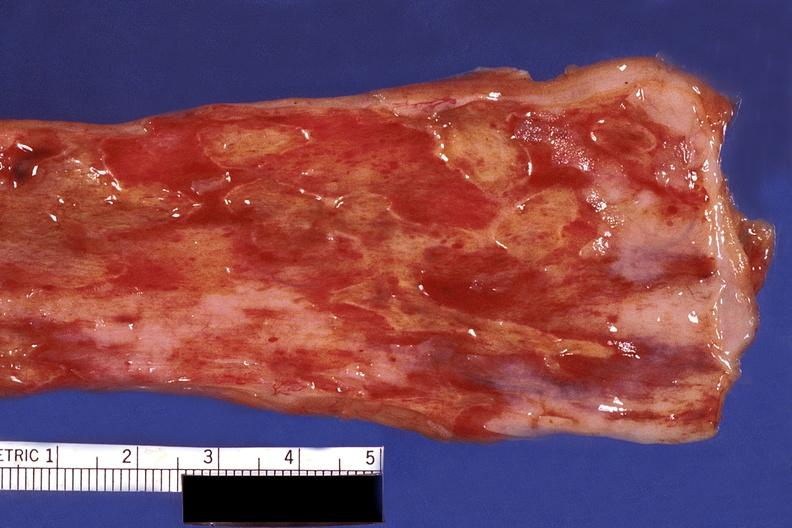does this image show esophagus, herpes, ulcers?
Answer the question using a single word or phrase. Yes 